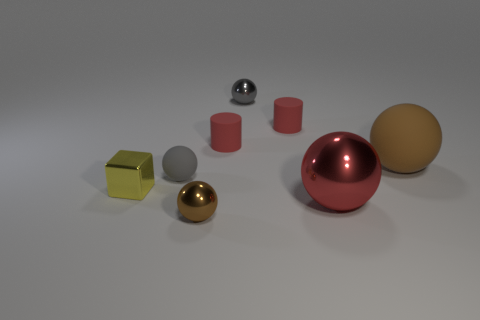Can you infer anything about the lighting of the scene? The shadows cast by the objects suggest a single, diffused light source above and slightly to the front-right of the scene, creating a soft and even illumination. Is there any reflection that indicates the position of the light source? Yes, the reflections on the polished metallic surfaces, particularly the silver sphere, show a highlight that suggests the light source's position relative to the objects. 